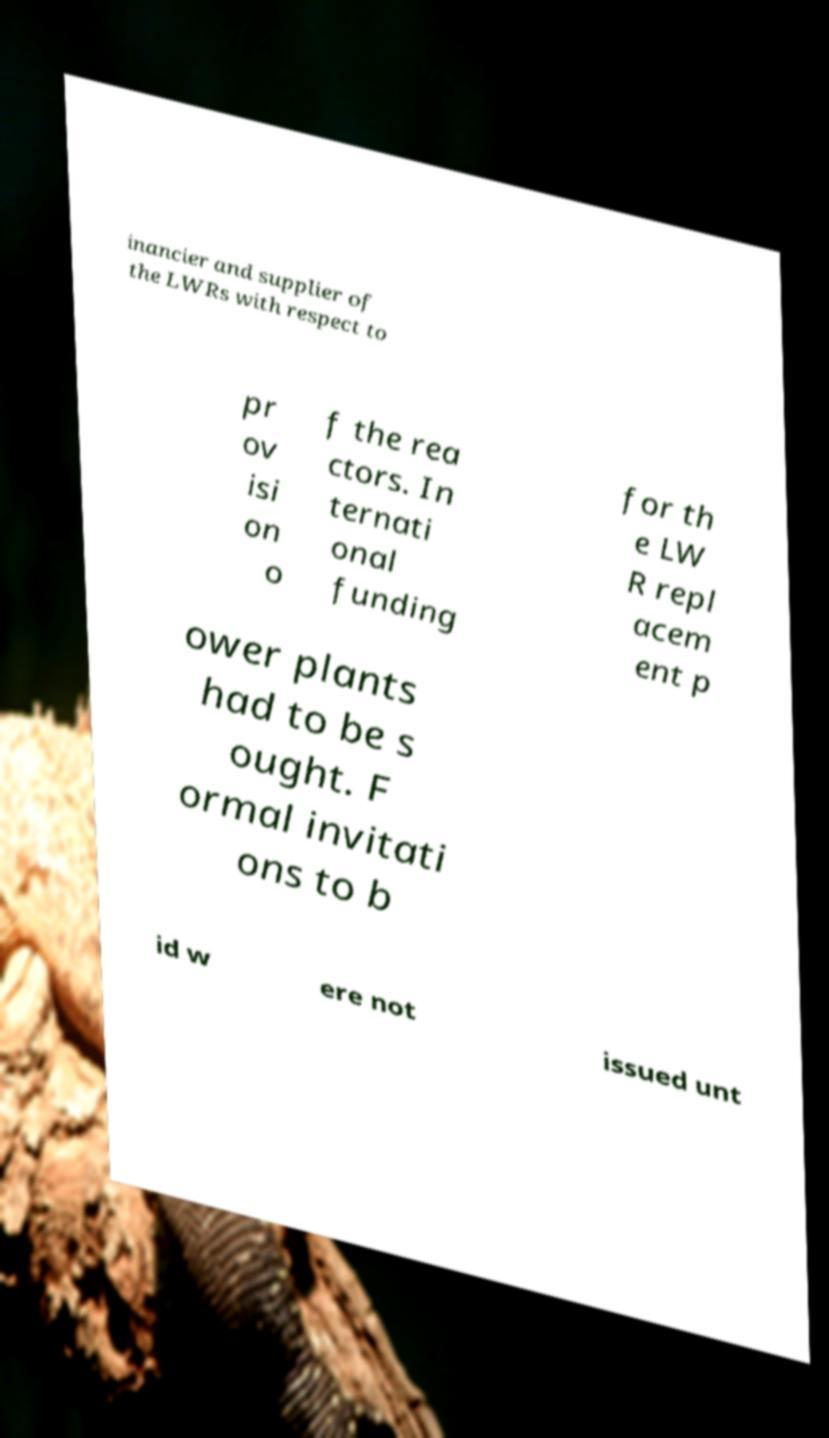I need the written content from this picture converted into text. Can you do that? inancier and supplier of the LWRs with respect to pr ov isi on o f the rea ctors. In ternati onal funding for th e LW R repl acem ent p ower plants had to be s ought. F ormal invitati ons to b id w ere not issued unt 